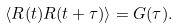Convert formula to latex. <formula><loc_0><loc_0><loc_500><loc_500>\langle R ( t ) R ( t + \tau ) \rangle = G ( \tau ) .</formula> 